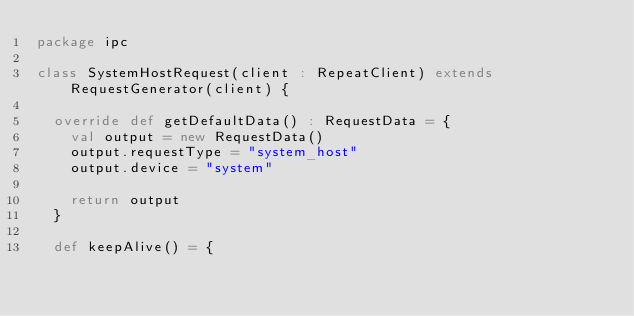<code> <loc_0><loc_0><loc_500><loc_500><_Scala_>package ipc

class SystemHostRequest(client : RepeatClient) extends RequestGenerator(client) {
  
  override def getDefaultData() : RequestData = {
    val output = new RequestData()
    output.requestType = "system_host"
    output.device = "system"
    
    return output
  }
  
  def keepAlive() = {</code> 